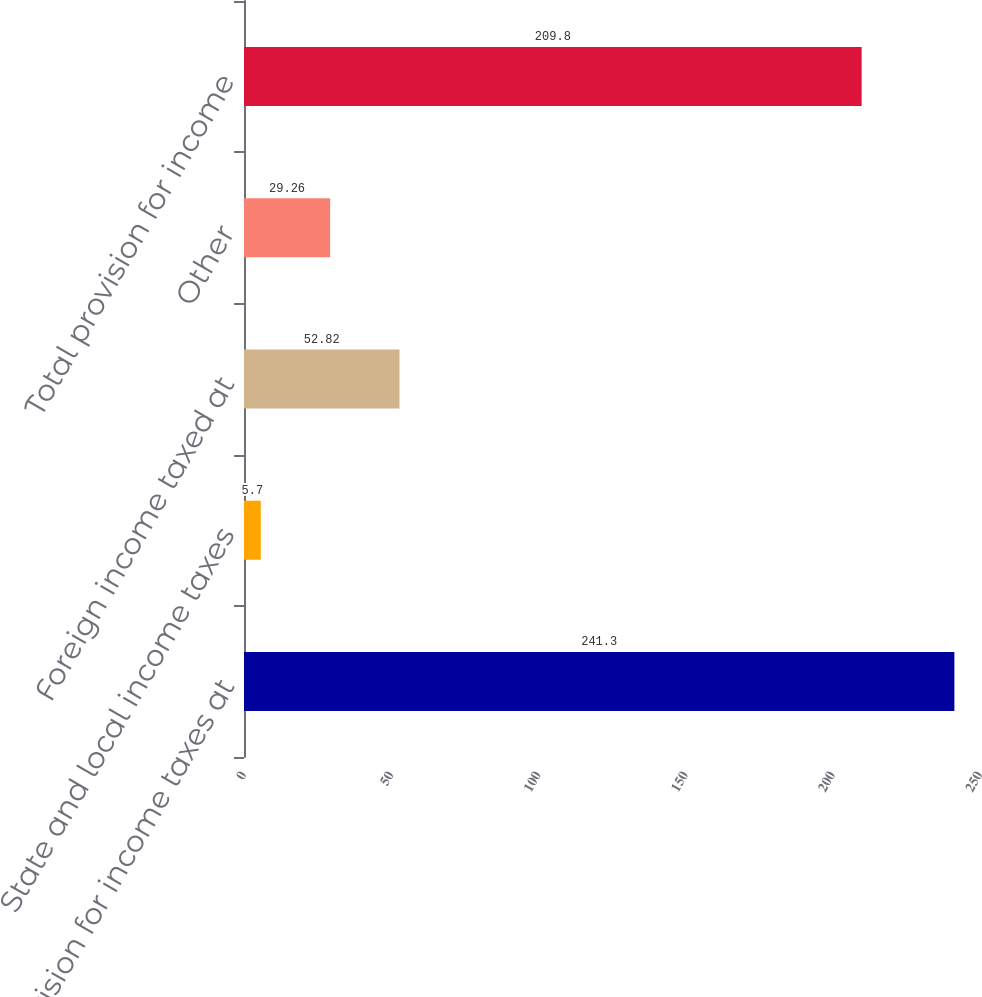<chart> <loc_0><loc_0><loc_500><loc_500><bar_chart><fcel>Provision for income taxes at<fcel>State and local income taxes<fcel>Foreign income taxed at<fcel>Other<fcel>Total provision for income<nl><fcel>241.3<fcel>5.7<fcel>52.82<fcel>29.26<fcel>209.8<nl></chart> 